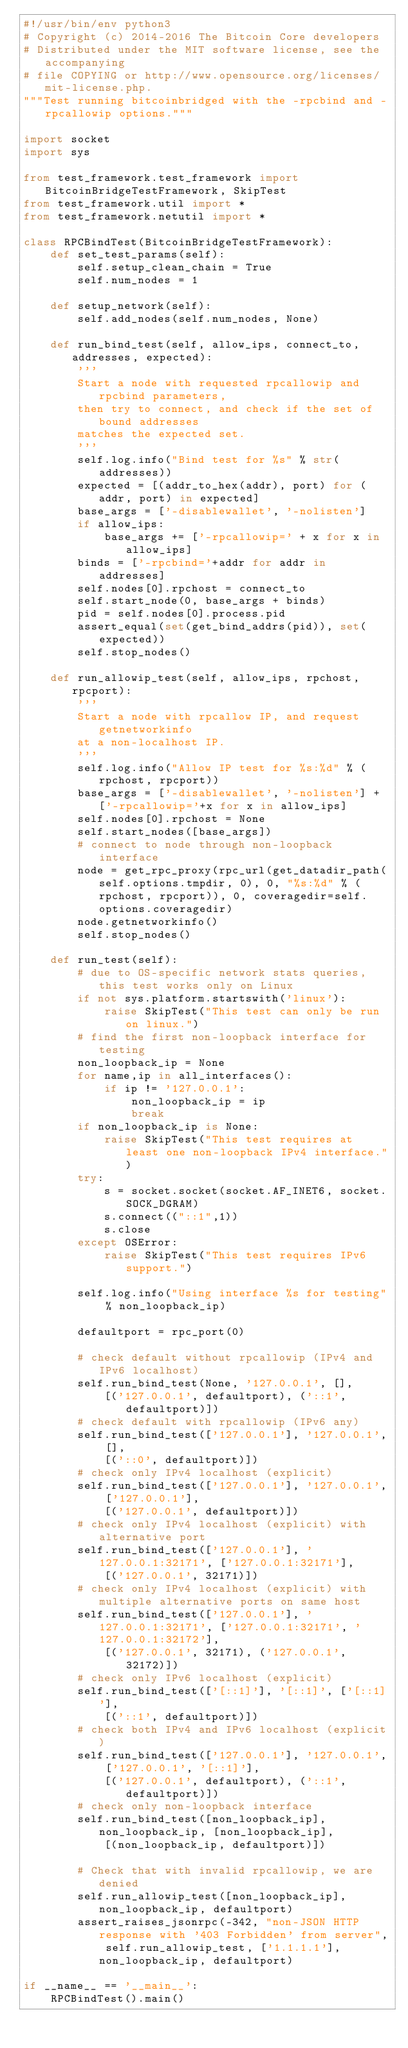Convert code to text. <code><loc_0><loc_0><loc_500><loc_500><_Python_>#!/usr/bin/env python3
# Copyright (c) 2014-2016 The Bitcoin Core developers
# Distributed under the MIT software license, see the accompanying
# file COPYING or http://www.opensource.org/licenses/mit-license.php.
"""Test running bitcoinbridged with the -rpcbind and -rpcallowip options."""

import socket
import sys

from test_framework.test_framework import BitcoinBridgeTestFramework, SkipTest
from test_framework.util import *
from test_framework.netutil import *

class RPCBindTest(BitcoinBridgeTestFramework):
    def set_test_params(self):
        self.setup_clean_chain = True
        self.num_nodes = 1

    def setup_network(self):
        self.add_nodes(self.num_nodes, None)

    def run_bind_test(self, allow_ips, connect_to, addresses, expected):
        '''
        Start a node with requested rpcallowip and rpcbind parameters,
        then try to connect, and check if the set of bound addresses
        matches the expected set.
        '''
        self.log.info("Bind test for %s" % str(addresses))
        expected = [(addr_to_hex(addr), port) for (addr, port) in expected]
        base_args = ['-disablewallet', '-nolisten']
        if allow_ips:
            base_args += ['-rpcallowip=' + x for x in allow_ips]
        binds = ['-rpcbind='+addr for addr in addresses]
        self.nodes[0].rpchost = connect_to
        self.start_node(0, base_args + binds)
        pid = self.nodes[0].process.pid
        assert_equal(set(get_bind_addrs(pid)), set(expected))
        self.stop_nodes()

    def run_allowip_test(self, allow_ips, rpchost, rpcport):
        '''
        Start a node with rpcallow IP, and request getnetworkinfo
        at a non-localhost IP.
        '''
        self.log.info("Allow IP test for %s:%d" % (rpchost, rpcport))
        base_args = ['-disablewallet', '-nolisten'] + ['-rpcallowip='+x for x in allow_ips]
        self.nodes[0].rpchost = None
        self.start_nodes([base_args])
        # connect to node through non-loopback interface
        node = get_rpc_proxy(rpc_url(get_datadir_path(self.options.tmpdir, 0), 0, "%s:%d" % (rpchost, rpcport)), 0, coveragedir=self.options.coveragedir)
        node.getnetworkinfo()
        self.stop_nodes()

    def run_test(self):
        # due to OS-specific network stats queries, this test works only on Linux
        if not sys.platform.startswith('linux'):
            raise SkipTest("This test can only be run on linux.")
        # find the first non-loopback interface for testing
        non_loopback_ip = None
        for name,ip in all_interfaces():
            if ip != '127.0.0.1':
                non_loopback_ip = ip
                break
        if non_loopback_ip is None:
            raise SkipTest("This test requires at least one non-loopback IPv4 interface.")
        try:
            s = socket.socket(socket.AF_INET6, socket.SOCK_DGRAM)
            s.connect(("::1",1))
            s.close
        except OSError:
            raise SkipTest("This test requires IPv6 support.")

        self.log.info("Using interface %s for testing" % non_loopback_ip)

        defaultport = rpc_port(0)

        # check default without rpcallowip (IPv4 and IPv6 localhost)
        self.run_bind_test(None, '127.0.0.1', [],
            [('127.0.0.1', defaultport), ('::1', defaultport)])
        # check default with rpcallowip (IPv6 any)
        self.run_bind_test(['127.0.0.1'], '127.0.0.1', [],
            [('::0', defaultport)])
        # check only IPv4 localhost (explicit)
        self.run_bind_test(['127.0.0.1'], '127.0.0.1', ['127.0.0.1'],
            [('127.0.0.1', defaultport)])
        # check only IPv4 localhost (explicit) with alternative port
        self.run_bind_test(['127.0.0.1'], '127.0.0.1:32171', ['127.0.0.1:32171'],
            [('127.0.0.1', 32171)])
        # check only IPv4 localhost (explicit) with multiple alternative ports on same host
        self.run_bind_test(['127.0.0.1'], '127.0.0.1:32171', ['127.0.0.1:32171', '127.0.0.1:32172'],
            [('127.0.0.1', 32171), ('127.0.0.1', 32172)])
        # check only IPv6 localhost (explicit)
        self.run_bind_test(['[::1]'], '[::1]', ['[::1]'],
            [('::1', defaultport)])
        # check both IPv4 and IPv6 localhost (explicit)
        self.run_bind_test(['127.0.0.1'], '127.0.0.1', ['127.0.0.1', '[::1]'],
            [('127.0.0.1', defaultport), ('::1', defaultport)])
        # check only non-loopback interface
        self.run_bind_test([non_loopback_ip], non_loopback_ip, [non_loopback_ip],
            [(non_loopback_ip, defaultport)])

        # Check that with invalid rpcallowip, we are denied
        self.run_allowip_test([non_loopback_ip], non_loopback_ip, defaultport)
        assert_raises_jsonrpc(-342, "non-JSON HTTP response with '403 Forbidden' from server", self.run_allowip_test, ['1.1.1.1'], non_loopback_ip, defaultport)

if __name__ == '__main__':
    RPCBindTest().main()
</code> 